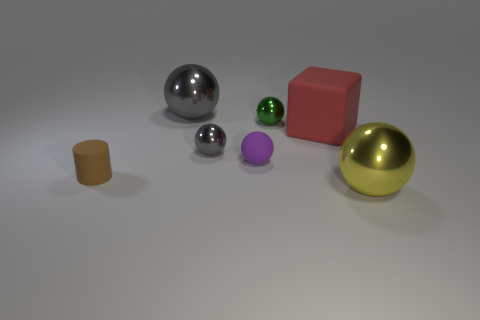What might be the purpose of having objects with different materials in this image? The variety of materials ranging from metallic and shiny to matte and possibly plastic, suggests a purpose for demonstrating how different textures and surfaces interact with light. It could be an educational tool for artists learning about rendering techniques or for photographers to practice capturing different material qualities. 